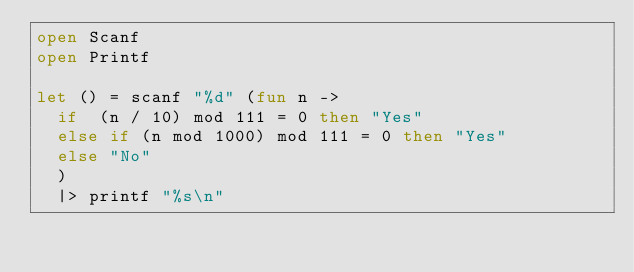Convert code to text. <code><loc_0><loc_0><loc_500><loc_500><_OCaml_>open Scanf
open Printf

let () = scanf "%d" (fun n ->
  if  (n / 10) mod 111 = 0 then "Yes"
  else if (n mod 1000) mod 111 = 0 then "Yes"
  else "No"
  )
  |> printf "%s\n"</code> 